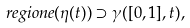<formula> <loc_0><loc_0><loc_500><loc_500>\ r e g i o n e ( \eta ( t ) ) \supset \gamma ( [ 0 , 1 ] , t ) ,</formula> 